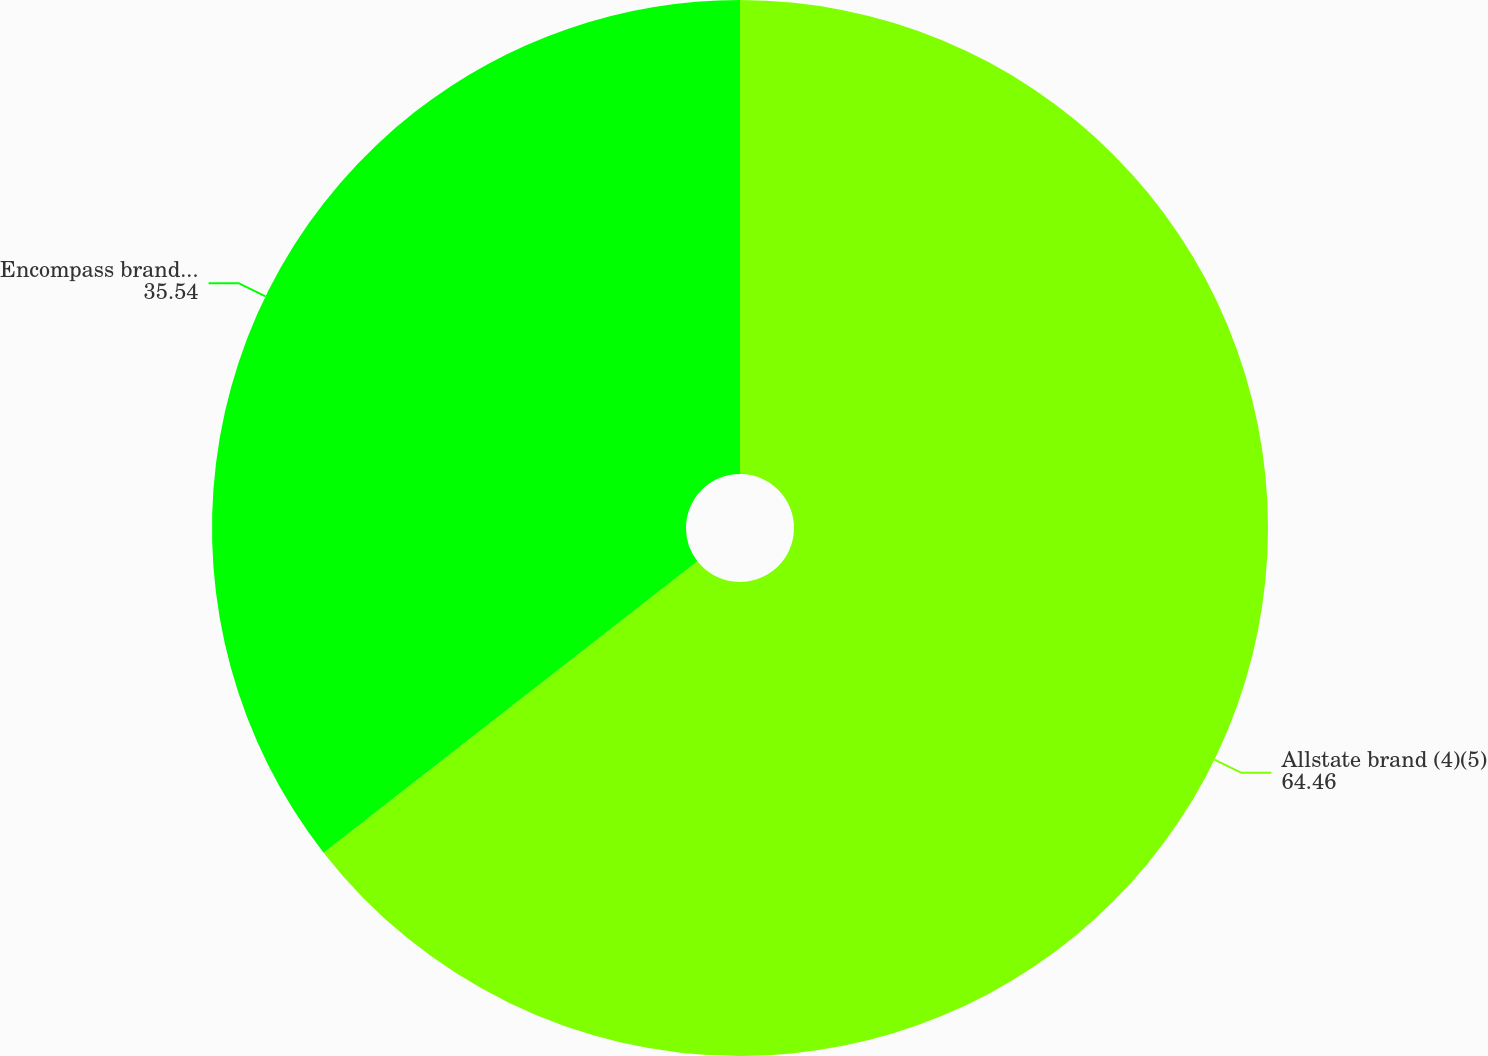Convert chart. <chart><loc_0><loc_0><loc_500><loc_500><pie_chart><fcel>Allstate brand (4)(5)<fcel>Encompass brand (4)<nl><fcel>64.46%<fcel>35.54%<nl></chart> 